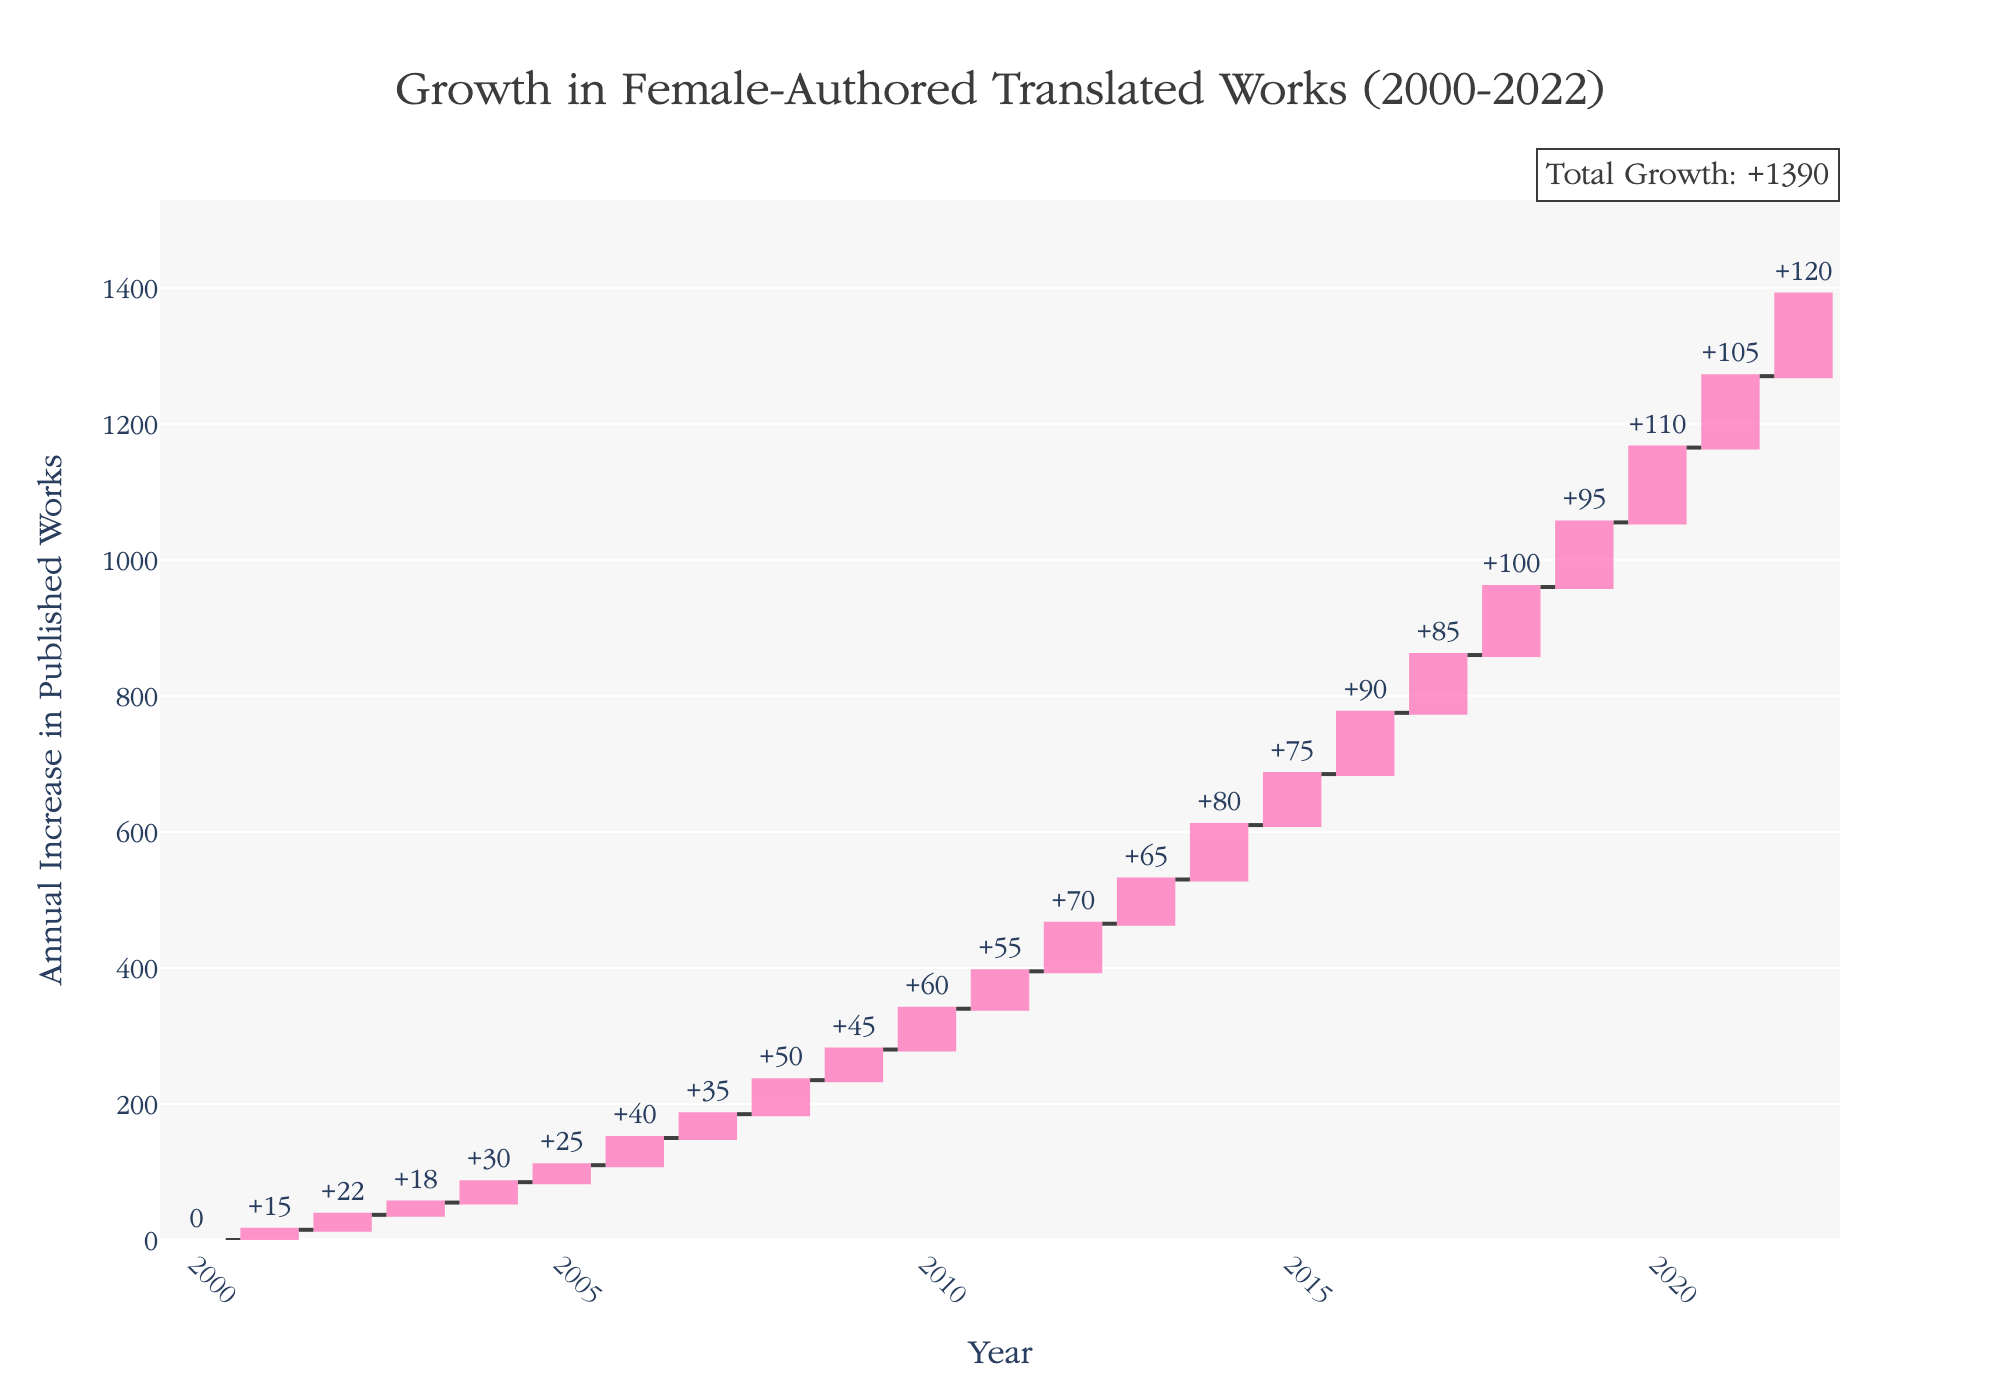How many years are shown in the chart? Count the number of years listed on the x-axis from 2000 to 2022.
Answer: 23 What is the title of the chart? The title is usually displayed at the top center of the chart and describes what the chart represents.
Answer: "Growth in Female-Authored Translated Works (2000-2022)" In which year did female-authored translated works see the highest increase? Look for the highest positive value in the chart or data points. The largest bar indicates the highest increase.
Answer: 2022 What was the cumulative increase in published works by 2011? Sum the annual increases for each year from 2000 to 2011: 0 + 15 + 22 + 18 + 30 + 25 + 40 + 35 + 50 + 45 + 60 + 55 = 395
Answer: 395 Which years saw increases greater than 80 published works? Identify the bars or points that are taller than or equal to the 80-mark on the y-axis.
Answer: 2014, 2016, 2018, 2020, 2022 By how much did the number of published works increase from 2015 to 2020? Subtract the cumulative increase up to 2015 from the cumulative increase up to 2020: (0 + 15 + 22 + 18 + 30 + 25 + 40 + 35 + 50 + 45 + 60 + 55 + 70 + 65 + 80 + 75 + 90 + 85 + 100 + 95 + 110) - (0 + 15 + 22 + 18 + 30 + 25 + 40 + 35 + 50 + 45 + 60 + 55 + 70 + 65 + 80 + 75) = 440
Answer: 440 Was there any year with a decrease in published works? Check the entire chart for bars or points representing negative values. If none are found, there are no decreases.
Answer: No How does the increase in 2015 compare to the increase in 2010? Identify the values for 2015 and 2010 and compare them: 75 > 60.
Answer: 2015 had a greater increase What was the total growth in published works over the 22-year period? The total growth is explicitly annotated in the figure's additional annotation, which sums up the annual increases.
Answer: 1200 How many years had an increase of exactly 45 published works? Count the number of occurrences of the value 45 in the data points or chart.
Answer: 1 